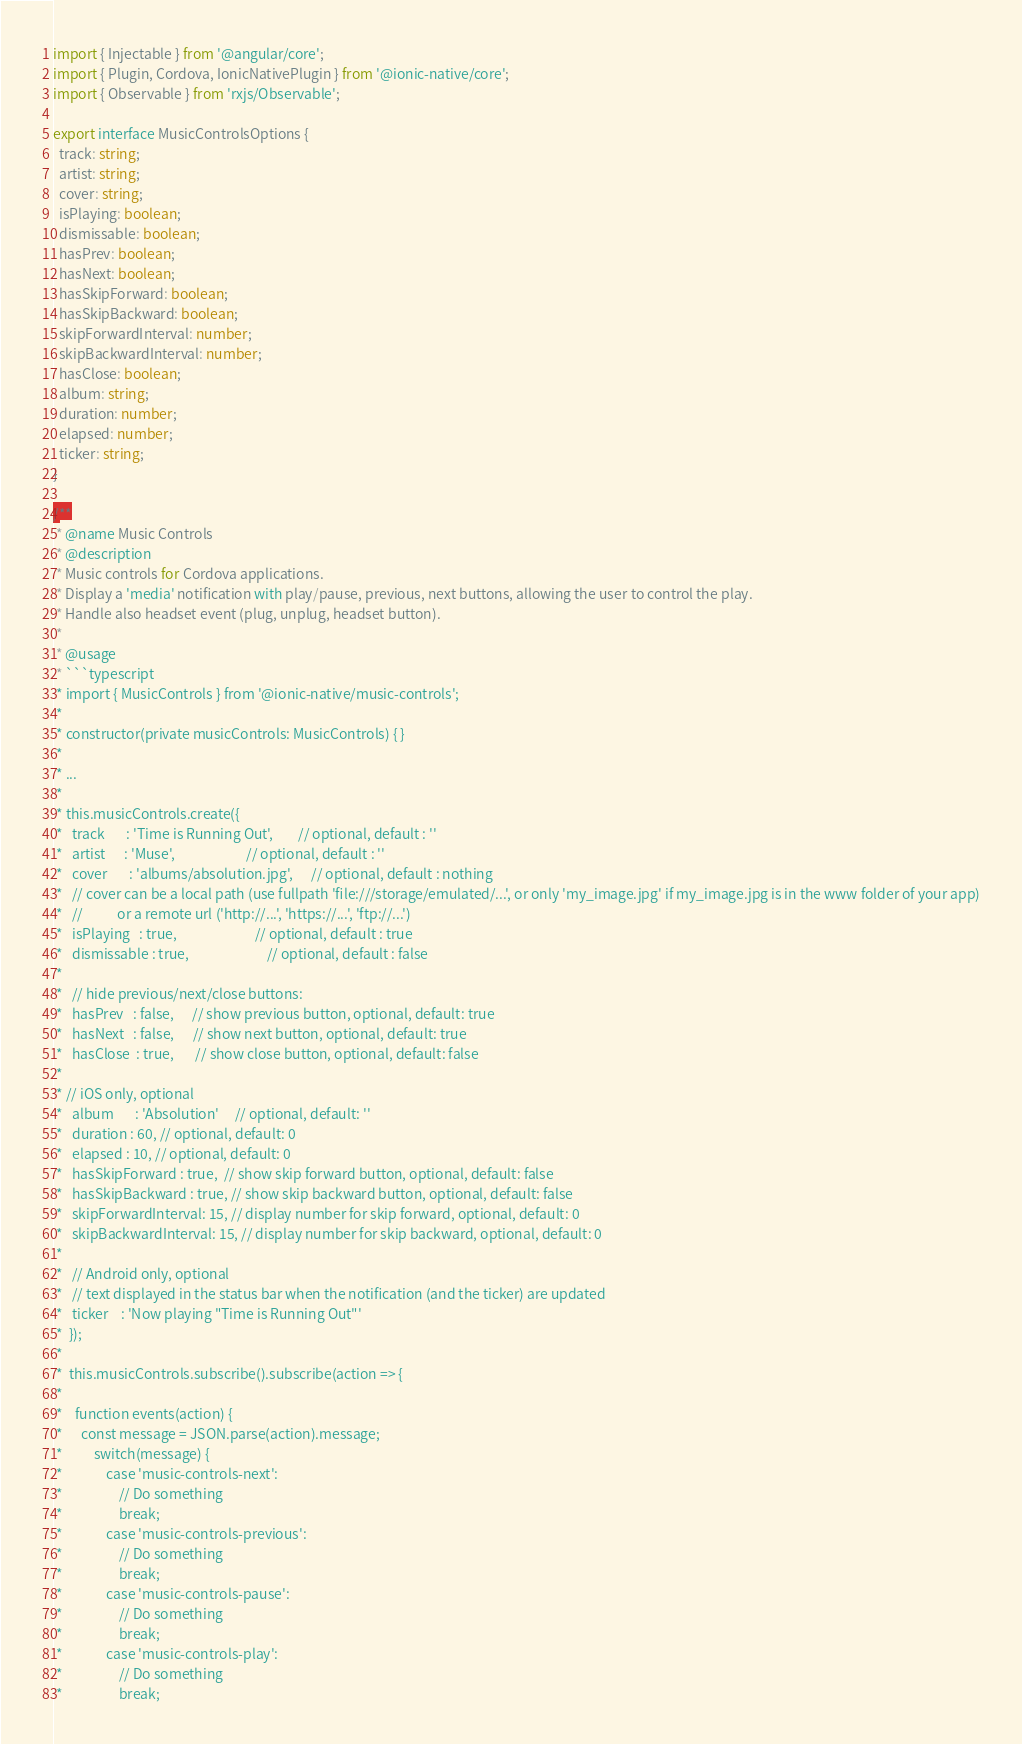Convert code to text. <code><loc_0><loc_0><loc_500><loc_500><_TypeScript_>import { Injectable } from '@angular/core';
import { Plugin, Cordova, IonicNativePlugin } from '@ionic-native/core';
import { Observable } from 'rxjs/Observable';

export interface MusicControlsOptions {
  track: string;
  artist: string;
  cover: string;
  isPlaying: boolean;
  dismissable: boolean;
  hasPrev: boolean;
  hasNext: boolean;
  hasSkipForward: boolean;
  hasSkipBackward: boolean;
  skipForwardInterval: number;
  skipBackwardInterval: number;
  hasClose: boolean;
  album: string;
  duration: number;
  elapsed: number;
  ticker: string;
}

/**
 * @name Music Controls
 * @description
 * Music controls for Cordova applications.
 * Display a 'media' notification with play/pause, previous, next buttons, allowing the user to control the play.
 * Handle also headset event (plug, unplug, headset button).
 *
 * @usage
 * ```typescript
 * import { MusicControls } from '@ionic-native/music-controls';
 *
 * constructor(private musicControls: MusicControls) { }
 *
 * ...
 *
 * this.musicControls.create({
 *   track       : 'Time is Running Out',        // optional, default : ''
 *   artist      : 'Muse',                       // optional, default : ''
 *   cover       : 'albums/absolution.jpg',      // optional, default : nothing
 *   // cover can be a local path (use fullpath 'file:///storage/emulated/...', or only 'my_image.jpg' if my_image.jpg is in the www folder of your app)
 *   //           or a remote url ('http://...', 'https://...', 'ftp://...')
 *   isPlaying   : true,                         // optional, default : true
 *   dismissable : true,                         // optional, default : false
 *
 *   // hide previous/next/close buttons:
 *   hasPrev   : false,      // show previous button, optional, default: true
 *   hasNext   : false,      // show next button, optional, default: true
 *   hasClose  : true,       // show close button, optional, default: false
 *
 * // iOS only, optional
 *   album       : 'Absolution'     // optional, default: ''
 *   duration : 60, // optional, default: 0
 *   elapsed : 10, // optional, default: 0
 *   hasSkipForward : true,  // show skip forward button, optional, default: false
 *   hasSkipBackward : true, // show skip backward button, optional, default: false
 *   skipForwardInterval: 15, // display number for skip forward, optional, default: 0
 *   skipBackwardInterval: 15, // display number for skip backward, optional, default: 0
 *
 *   // Android only, optional
 *   // text displayed in the status bar when the notification (and the ticker) are updated
 *   ticker    : 'Now playing "Time is Running Out"'
 *  });
 *
 *  this.musicControls.subscribe().subscribe(action => {
 *
 *    function events(action) {
 *      const message = JSON.parse(action).message;
 *      	switch(message) {
 *      		case 'music-controls-next':
 *      			// Do something
 *      			break;
 *      		case 'music-controls-previous':
 *      			// Do something
 *      			break;
 *      		case 'music-controls-pause':
 *      			// Do something
 *      			break;
 *      		case 'music-controls-play':
 *      			// Do something
 *      			break;</code> 